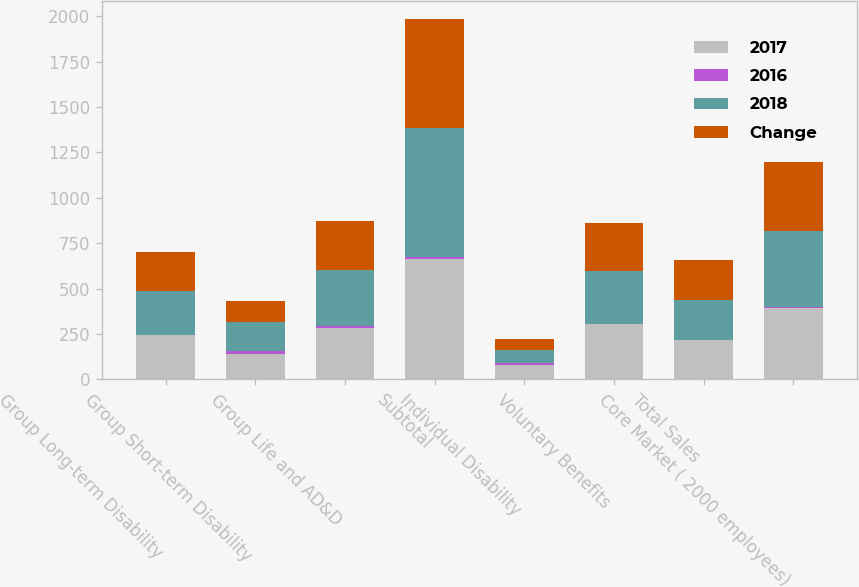Convert chart to OTSL. <chart><loc_0><loc_0><loc_500><loc_500><stacked_bar_chart><ecel><fcel>Group Long-term Disability<fcel>Group Short-term Disability<fcel>Group Life and AD&D<fcel>Subtotal<fcel>Individual Disability<fcel>Voluntary Benefits<fcel>Total Sales<fcel>Core Market ( 2000 employees)<nl><fcel>2017<fcel>243.8<fcel>138.7<fcel>282.4<fcel>664.9<fcel>77.2<fcel>303.1<fcel>217.8<fcel>395.1<nl><fcel>2016<fcel>1.2<fcel>14.6<fcel>9<fcel>6.9<fcel>13.7<fcel>3.6<fcel>1.3<fcel>5.2<nl><fcel>2018<fcel>240.8<fcel>162.5<fcel>310.5<fcel>713.8<fcel>67.9<fcel>292.5<fcel>217.8<fcel>416.9<nl><fcel>Change<fcel>217.8<fcel>114.6<fcel>270.1<fcel>602.5<fcel>65.1<fcel>261.7<fcel>217.8<fcel>378.1<nl></chart> 